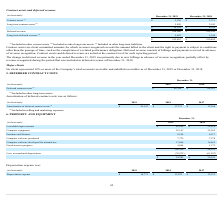According to Pegasystems's financial document, What is the change in deferred revenue in the year ended December 31, 2019 primarily due to? new billings in advance of revenue recognition, partially offset by revenue recognized during the period that was included in deferred revenue at December 31, 2018. The document states: "year ended December 31, 2019 was primarily due to new billings in advance of revenue recognition, partially offset by revenue recognized during the pe..." Also, What are contract assets and long-term contract assets respectively classified under? The document shows two values: other current assets and other long-term assets. From the document: "(1) Included in other current assets. (2) Included in other long-term assets. (3) Included in other long-term liabilities. Included in other current a..." Also, What are long-term deferred revenue respectively classified under? other long-term liabilities. The document states: "cluded in other long-term assets. (3) Included in other long-term liabilities...." Also, can you calculate: What is the percentage change in contract assets between 2018 and 2019? To answer this question, I need to perform calculations using the financial data. The calculation is: (5,558 - 3,711)/3,711 , which equals 49.77 (percentage). This is based on the information: "Contract assets (1) $ 5,558 $ 3,711 Contract assets (1) $ 5,558 $ 3,711..." The key data points involved are: 3,711, 5,558. Also, can you calculate: What is the percentage change in long-term contract assets between 2018 and 2019? To answer this question, I need to perform calculations using the financial data. The calculation is: (5,420 - 2,543)/2,543 , which equals 113.13 (percentage). This is based on the information: "Long-term contract assets (2) 5,420 2,543 Long-term contract assets (2) 5,420 2,543..." The key data points involved are: 2,543, 5,420. Also, can you calculate: What is the percentage change in long-term deferred revenue between 2018 and 2019? To answer this question, I need to perform calculations using the financial data. The calculation is: (5,407 - 5,344)/5,344 , which equals 1.18 (percentage). This is based on the information: "Long-term deferred revenue (3) 5,407 5,344 Long-term deferred revenue (3) 5,407 5,344..." The key data points involved are: 5,344, 5,407. 